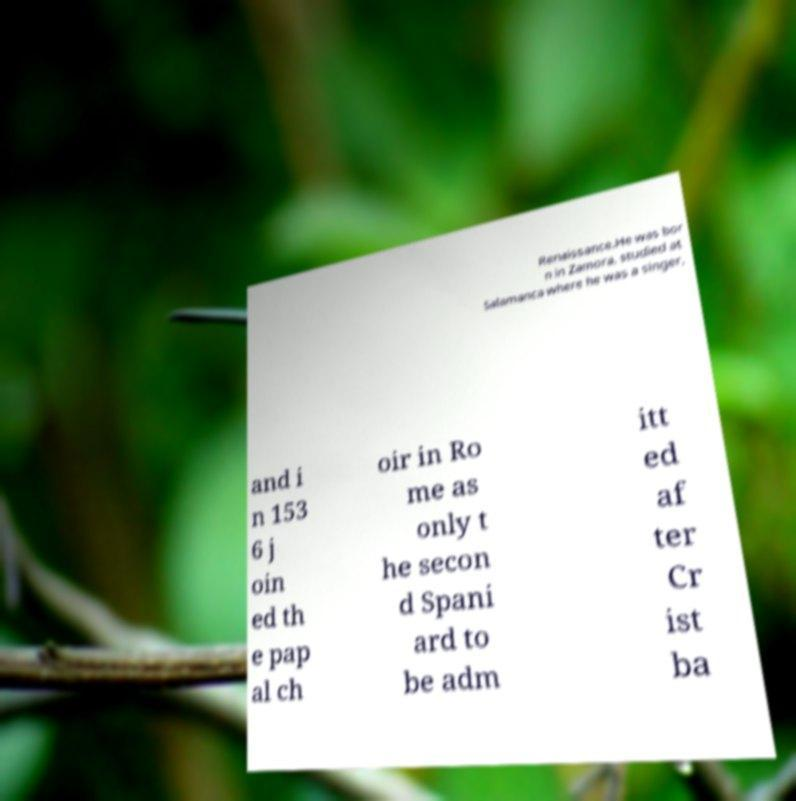Could you assist in decoding the text presented in this image and type it out clearly? Renaissance.He was bor n in Zamora, studied at Salamanca where he was a singer, and i n 153 6 j oin ed th e pap al ch oir in Ro me as only t he secon d Spani ard to be adm itt ed af ter Cr ist ba 